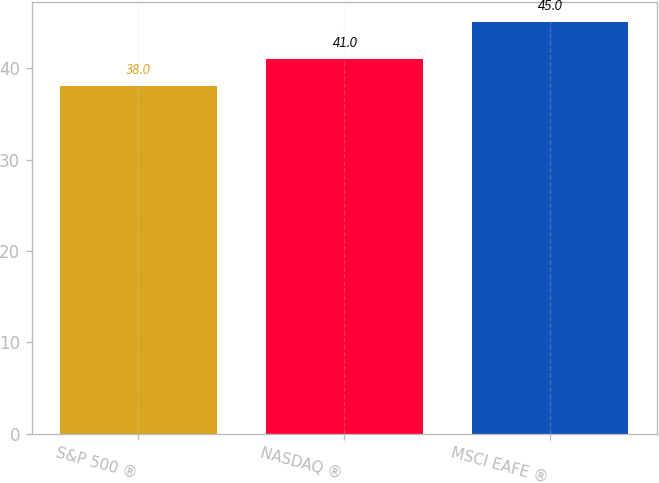Convert chart. <chart><loc_0><loc_0><loc_500><loc_500><bar_chart><fcel>S&P 500 ®<fcel>NASDAQ ®<fcel>MSCI EAFE ®<nl><fcel>38<fcel>41<fcel>45<nl></chart> 